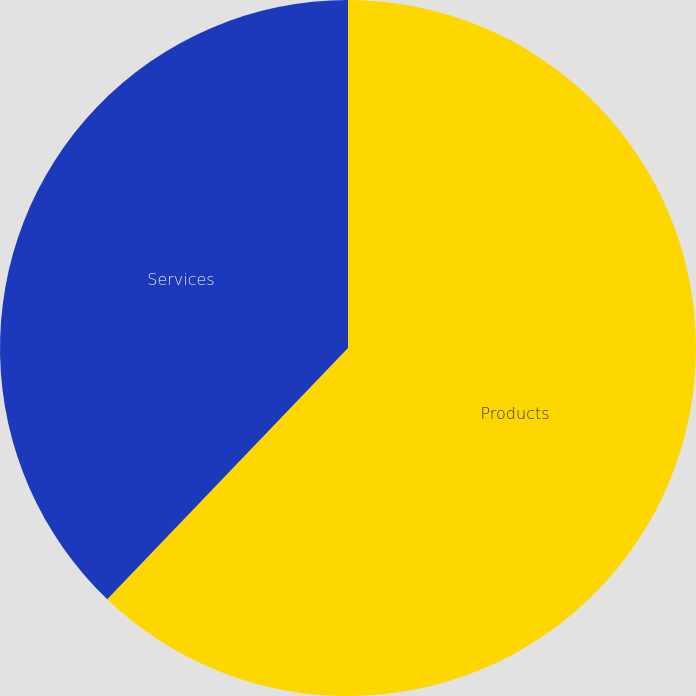<chart> <loc_0><loc_0><loc_500><loc_500><pie_chart><fcel>Products<fcel>Services<nl><fcel>62.16%<fcel>37.84%<nl></chart> 